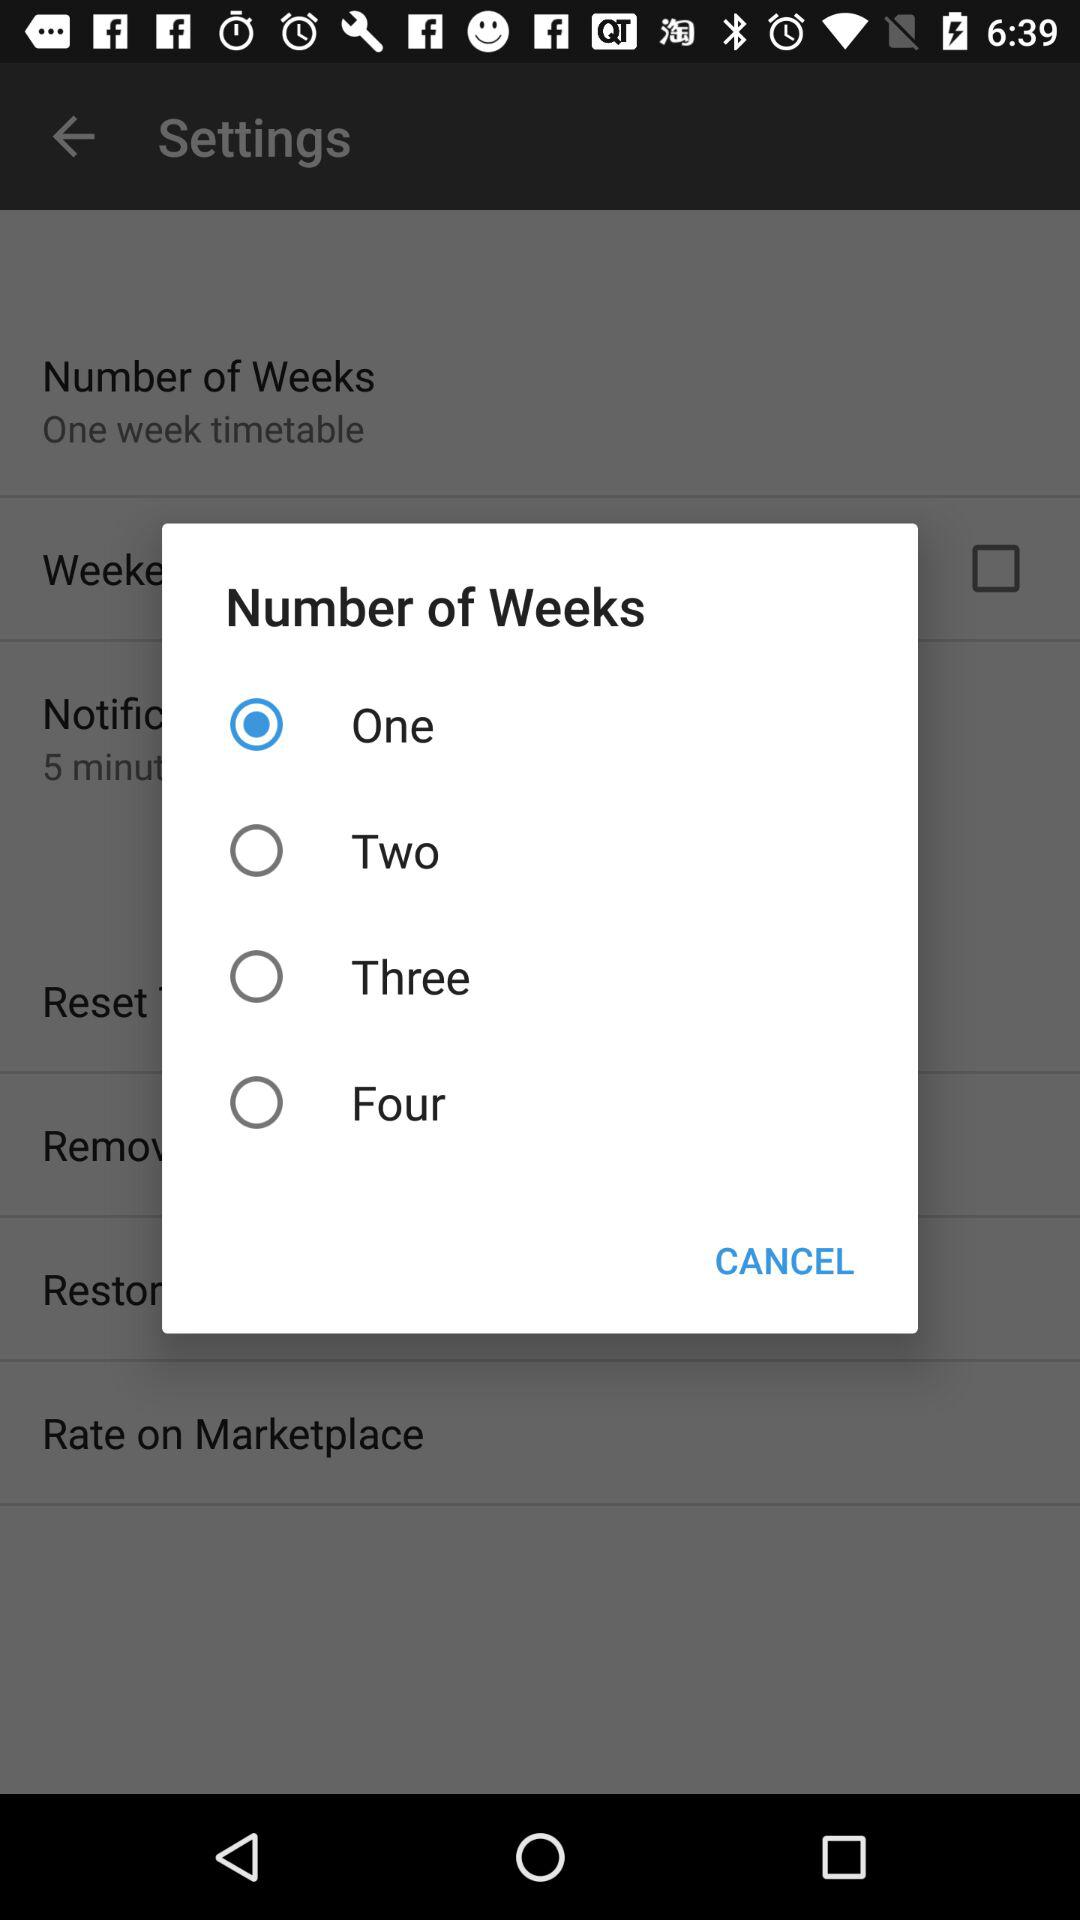How many weeks are available to select?
Answer the question using a single word or phrase. 4 